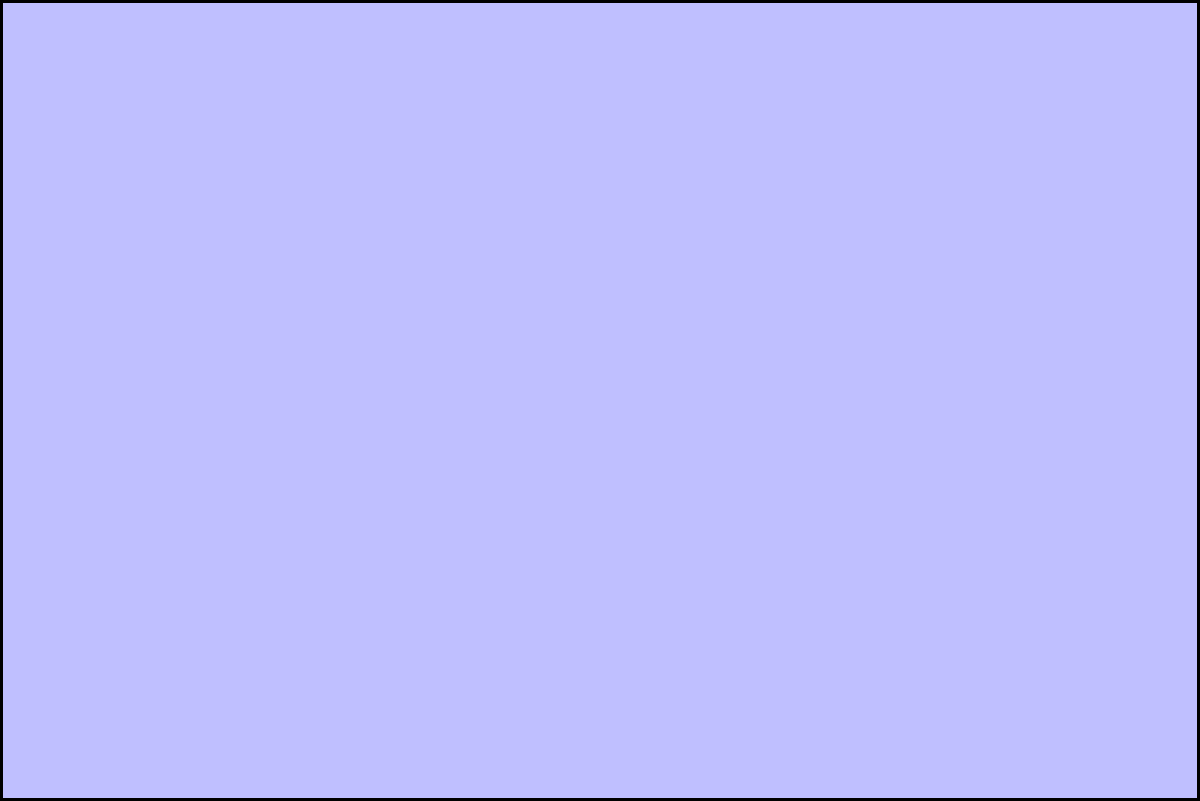Calculate the total area of the complex shape shown in the diagram. The shape consists of a rectangle, a semicircle on top of the rectangle, and an isosceles triangle above the semicircle. The rectangle has a width of 6 units and a height of 4 units. The semicircle has a diameter equal to the width of the rectangle. The isosceles triangle has a base width of 3 units and a height of 2 units. To solve this problem, we'll calculate the area of each component and sum them up:

1. Rectangle area:
   $A_{rectangle} = width \times height = 6 \times 4 = 24$ square units

2. Semicircle area:
   Radius of semicircle = $\frac{6}{2} = 3$ units
   $A_{semicircle} = \frac{1}{2} \times \pi r^2 = \frac{1}{2} \times \pi \times 3^2 = \frac{9\pi}{2}$ square units

3. Triangle area:
   $A_{triangle} = \frac{1}{2} \times base \times height = \frac{1}{2} \times 3 \times 2 = 3$ square units

Total area:
$$A_{total} = A_{rectangle} + A_{semicircle} + A_{triangle}$$
$$A_{total} = 24 + \frac{9\pi}{2} + 3$$
$$A_{total} = 27 + \frac{9\pi}{2}$$

To simplify:
$$A_{total} = 27 + 4.5\pi \approx 41.12$$ square units (rounded to 2 decimal places)
Answer: $27 + \frac{9\pi}{2}$ square units 